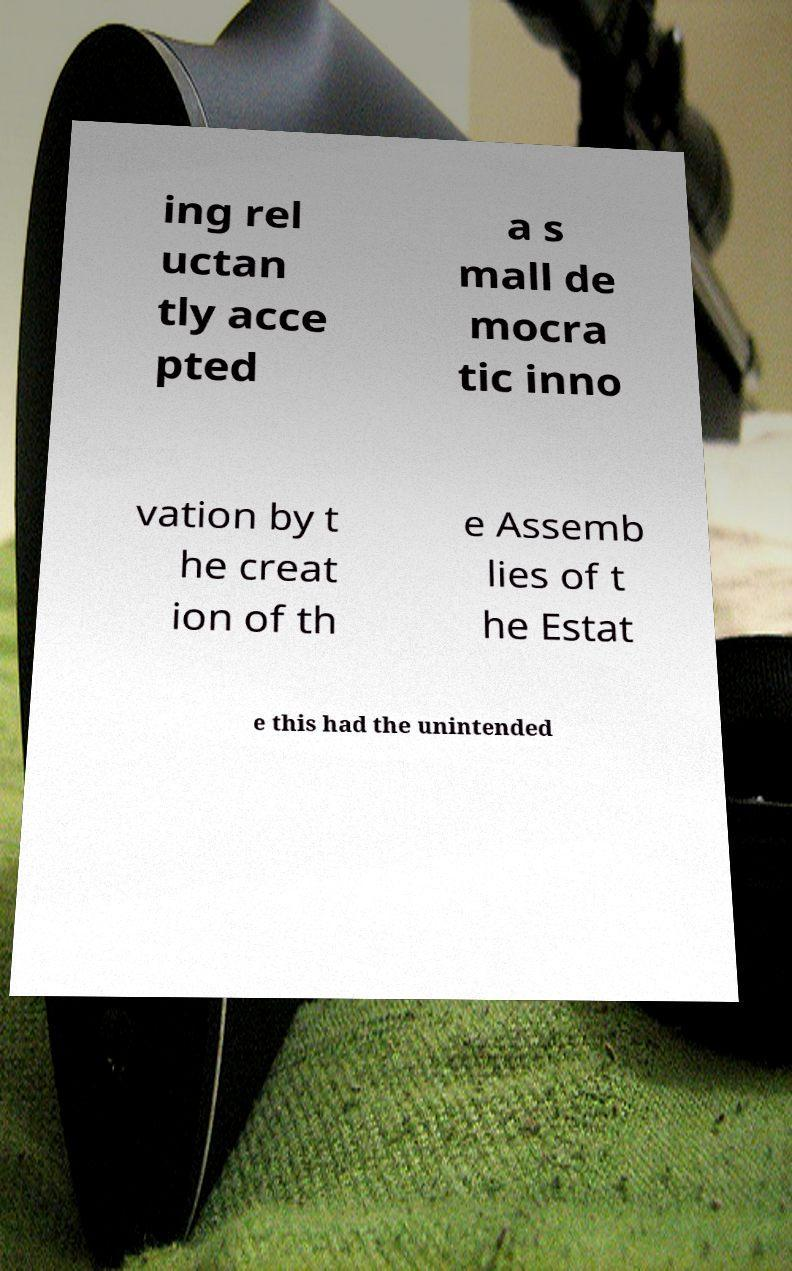Could you assist in decoding the text presented in this image and type it out clearly? ing rel uctan tly acce pted a s mall de mocra tic inno vation by t he creat ion of th e Assemb lies of t he Estat e this had the unintended 